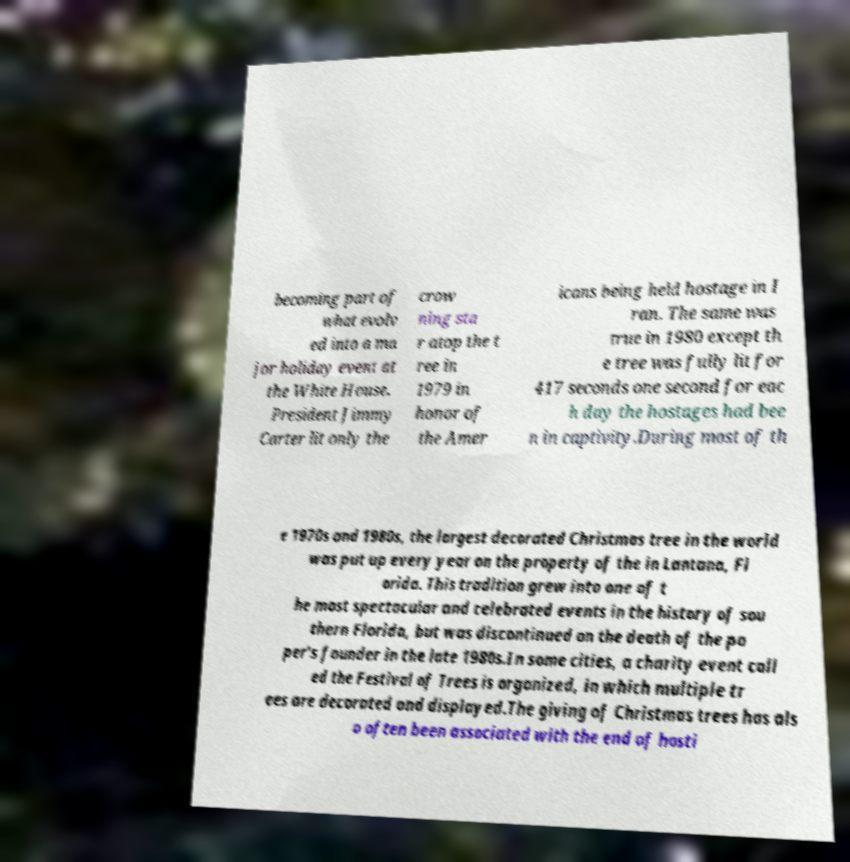For documentation purposes, I need the text within this image transcribed. Could you provide that? becoming part of what evolv ed into a ma jor holiday event at the White House. President Jimmy Carter lit only the crow ning sta r atop the t ree in 1979 in honor of the Amer icans being held hostage in I ran. The same was true in 1980 except th e tree was fully lit for 417 seconds one second for eac h day the hostages had bee n in captivity.During most of th e 1970s and 1980s, the largest decorated Christmas tree in the world was put up every year on the property of the in Lantana, Fl orida. This tradition grew into one of t he most spectacular and celebrated events in the history of sou thern Florida, but was discontinued on the death of the pa per's founder in the late 1980s.In some cities, a charity event call ed the Festival of Trees is organized, in which multiple tr ees are decorated and displayed.The giving of Christmas trees has als o often been associated with the end of hosti 